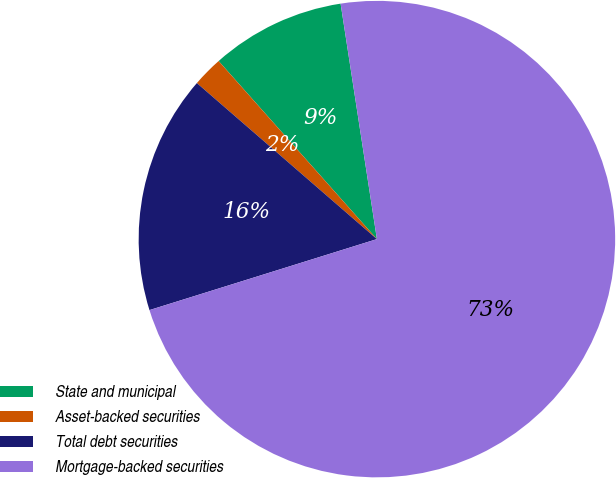Convert chart. <chart><loc_0><loc_0><loc_500><loc_500><pie_chart><fcel>State and municipal<fcel>Asset-backed securities<fcel>Total debt securities<fcel>Mortgage-backed securities<nl><fcel>9.13%<fcel>2.07%<fcel>16.18%<fcel>72.62%<nl></chart> 